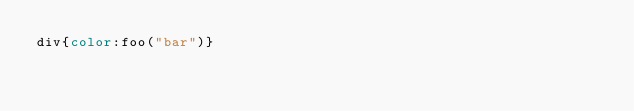<code> <loc_0><loc_0><loc_500><loc_500><_CSS_>div{color:foo("bar")}
</code> 